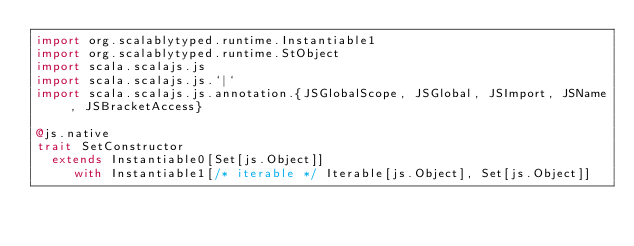<code> <loc_0><loc_0><loc_500><loc_500><_Scala_>import org.scalablytyped.runtime.Instantiable1
import org.scalablytyped.runtime.StObject
import scala.scalajs.js
import scala.scalajs.js.`|`
import scala.scalajs.js.annotation.{JSGlobalScope, JSGlobal, JSImport, JSName, JSBracketAccess}

@js.native
trait SetConstructor
  extends Instantiable0[Set[js.Object]]
     with Instantiable1[/* iterable */ Iterable[js.Object], Set[js.Object]]
</code> 